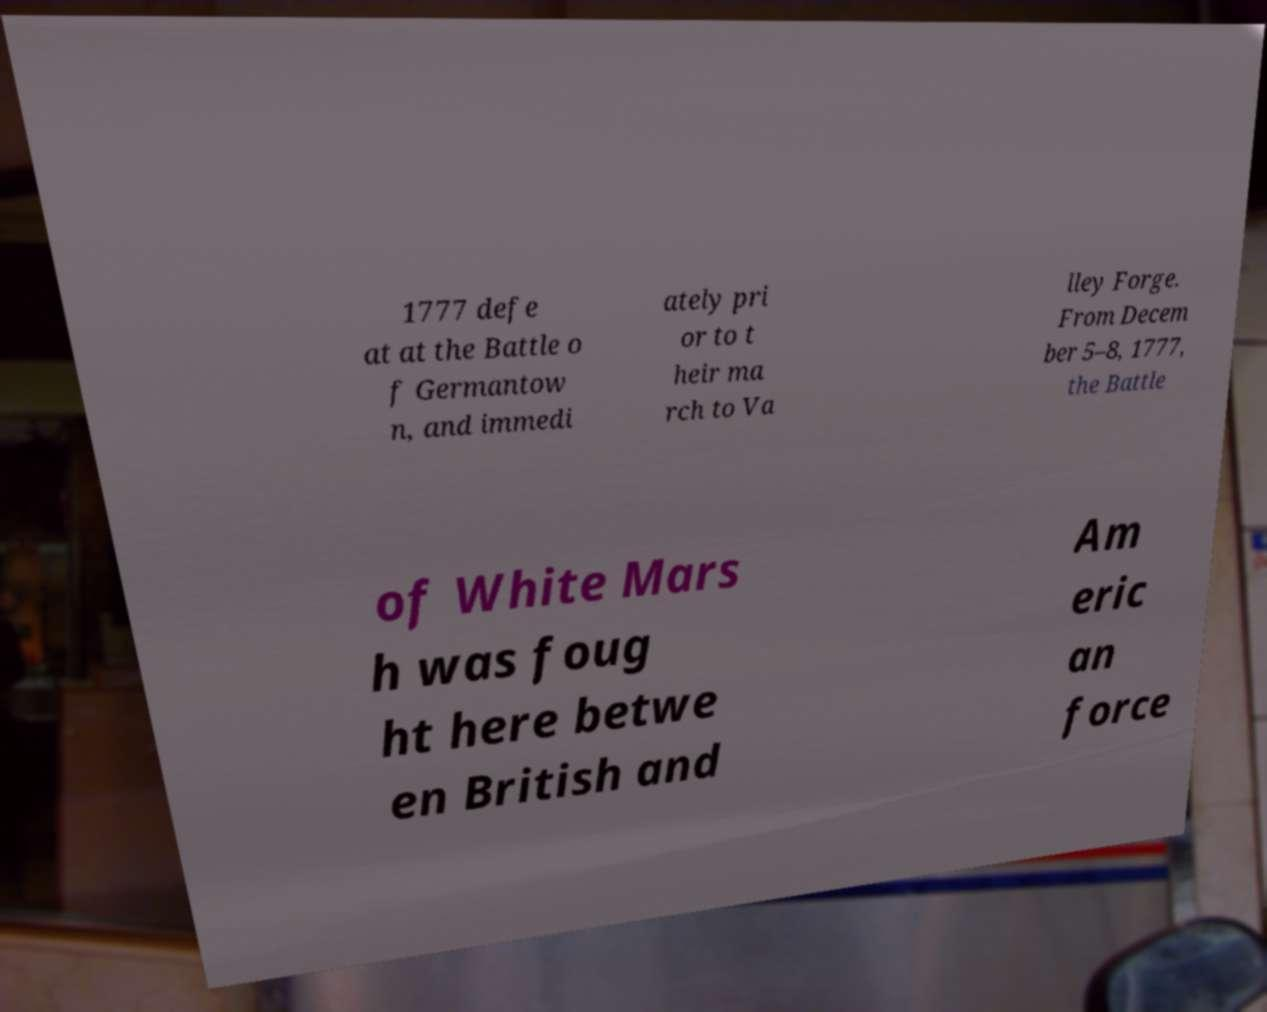Please read and relay the text visible in this image. What does it say? 1777 defe at at the Battle o f Germantow n, and immedi ately pri or to t heir ma rch to Va lley Forge. From Decem ber 5–8, 1777, the Battle of White Mars h was foug ht here betwe en British and Am eric an force 